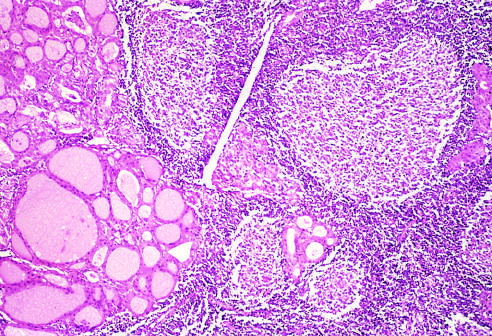how does the thyroid parenchyma contain a dense lymphocytic infiltrate?
Answer the question using a single word or phrase. With germinal centers 